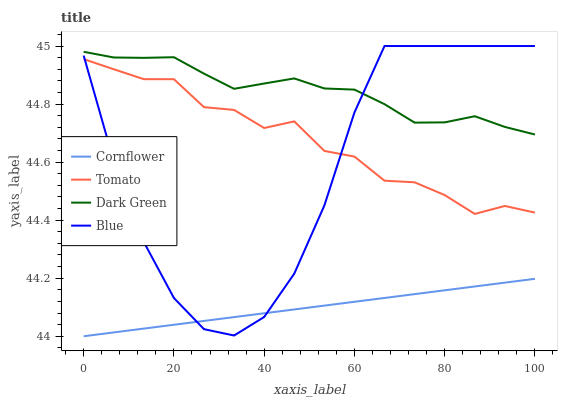Does Cornflower have the minimum area under the curve?
Answer yes or no. Yes. Does Dark Green have the maximum area under the curve?
Answer yes or no. Yes. Does Blue have the minimum area under the curve?
Answer yes or no. No. Does Blue have the maximum area under the curve?
Answer yes or no. No. Is Cornflower the smoothest?
Answer yes or no. Yes. Is Blue the roughest?
Answer yes or no. Yes. Is Blue the smoothest?
Answer yes or no. No. Is Cornflower the roughest?
Answer yes or no. No. Does Cornflower have the lowest value?
Answer yes or no. Yes. Does Blue have the lowest value?
Answer yes or no. No. Does Blue have the highest value?
Answer yes or no. Yes. Does Cornflower have the highest value?
Answer yes or no. No. Is Cornflower less than Tomato?
Answer yes or no. Yes. Is Dark Green greater than Cornflower?
Answer yes or no. Yes. Does Blue intersect Cornflower?
Answer yes or no. Yes. Is Blue less than Cornflower?
Answer yes or no. No. Is Blue greater than Cornflower?
Answer yes or no. No. Does Cornflower intersect Tomato?
Answer yes or no. No. 